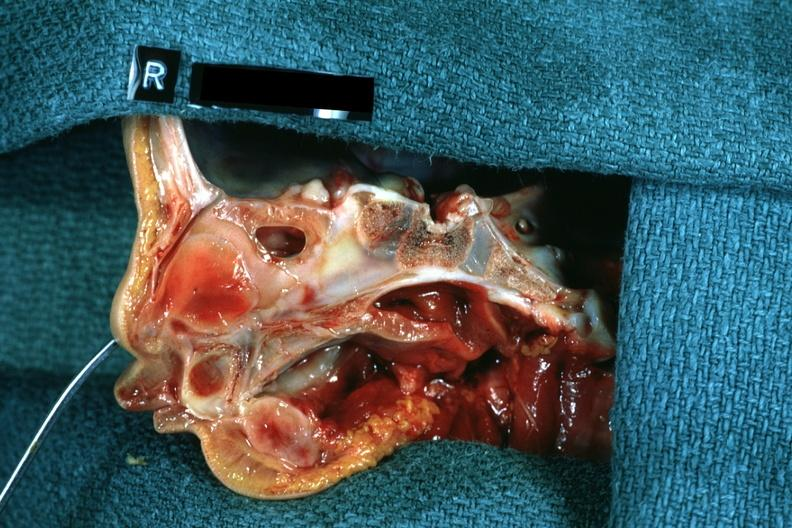what left was patent hemisection of nose?
Answer the question using a single word or phrase. Right side atresia 